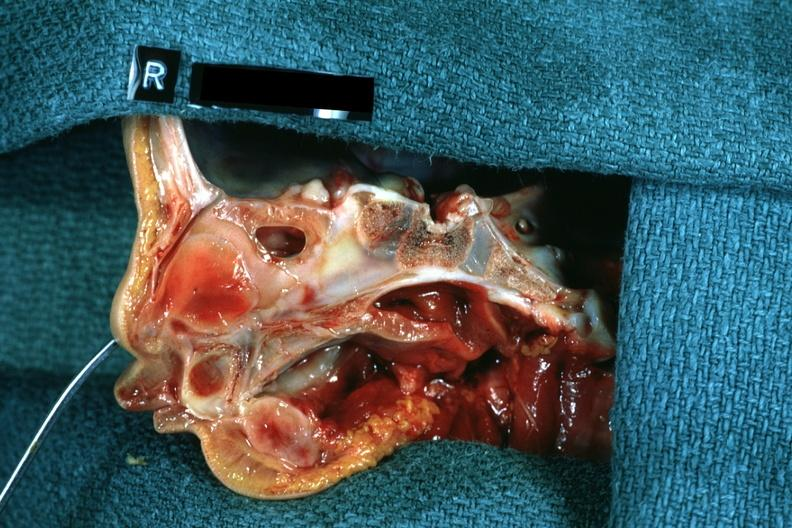what left was patent hemisection of nose?
Answer the question using a single word or phrase. Right side atresia 